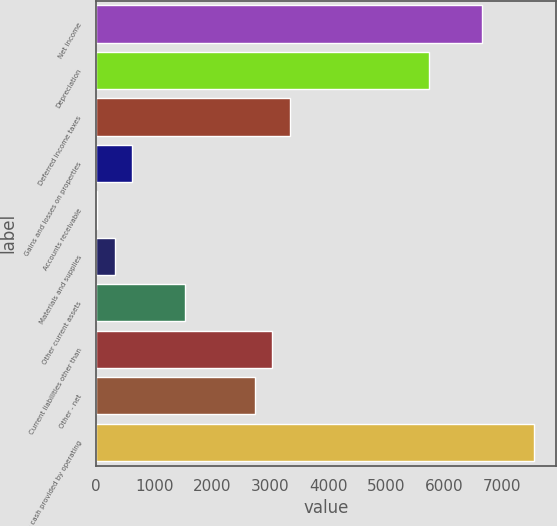Convert chart to OTSL. <chart><loc_0><loc_0><loc_500><loc_500><bar_chart><fcel>Net income<fcel>Depreciation<fcel>Deferred income taxes<fcel>Gains and losses on properties<fcel>Accounts receivable<fcel>Materials and supplies<fcel>Other current assets<fcel>Current liabilities other than<fcel>Other - net<fcel>Net cash provided by operating<nl><fcel>6647.2<fcel>5743.9<fcel>3335.1<fcel>625.2<fcel>23<fcel>324.1<fcel>1528.5<fcel>3034<fcel>2732.9<fcel>7550.5<nl></chart> 